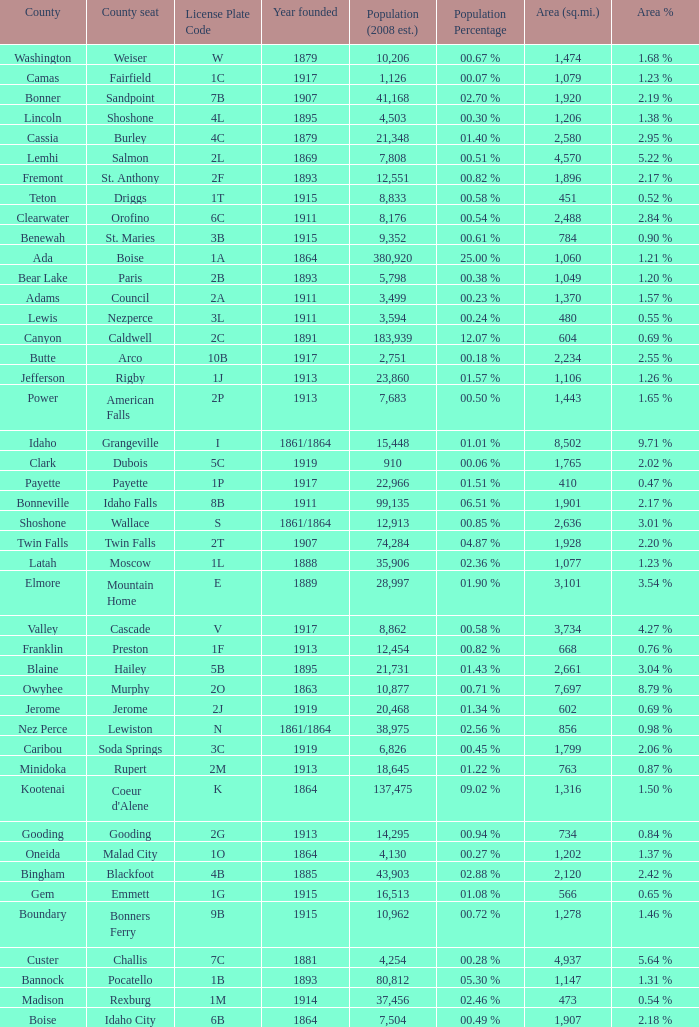What is the license plate code for the country with an area of 784? 3B. 